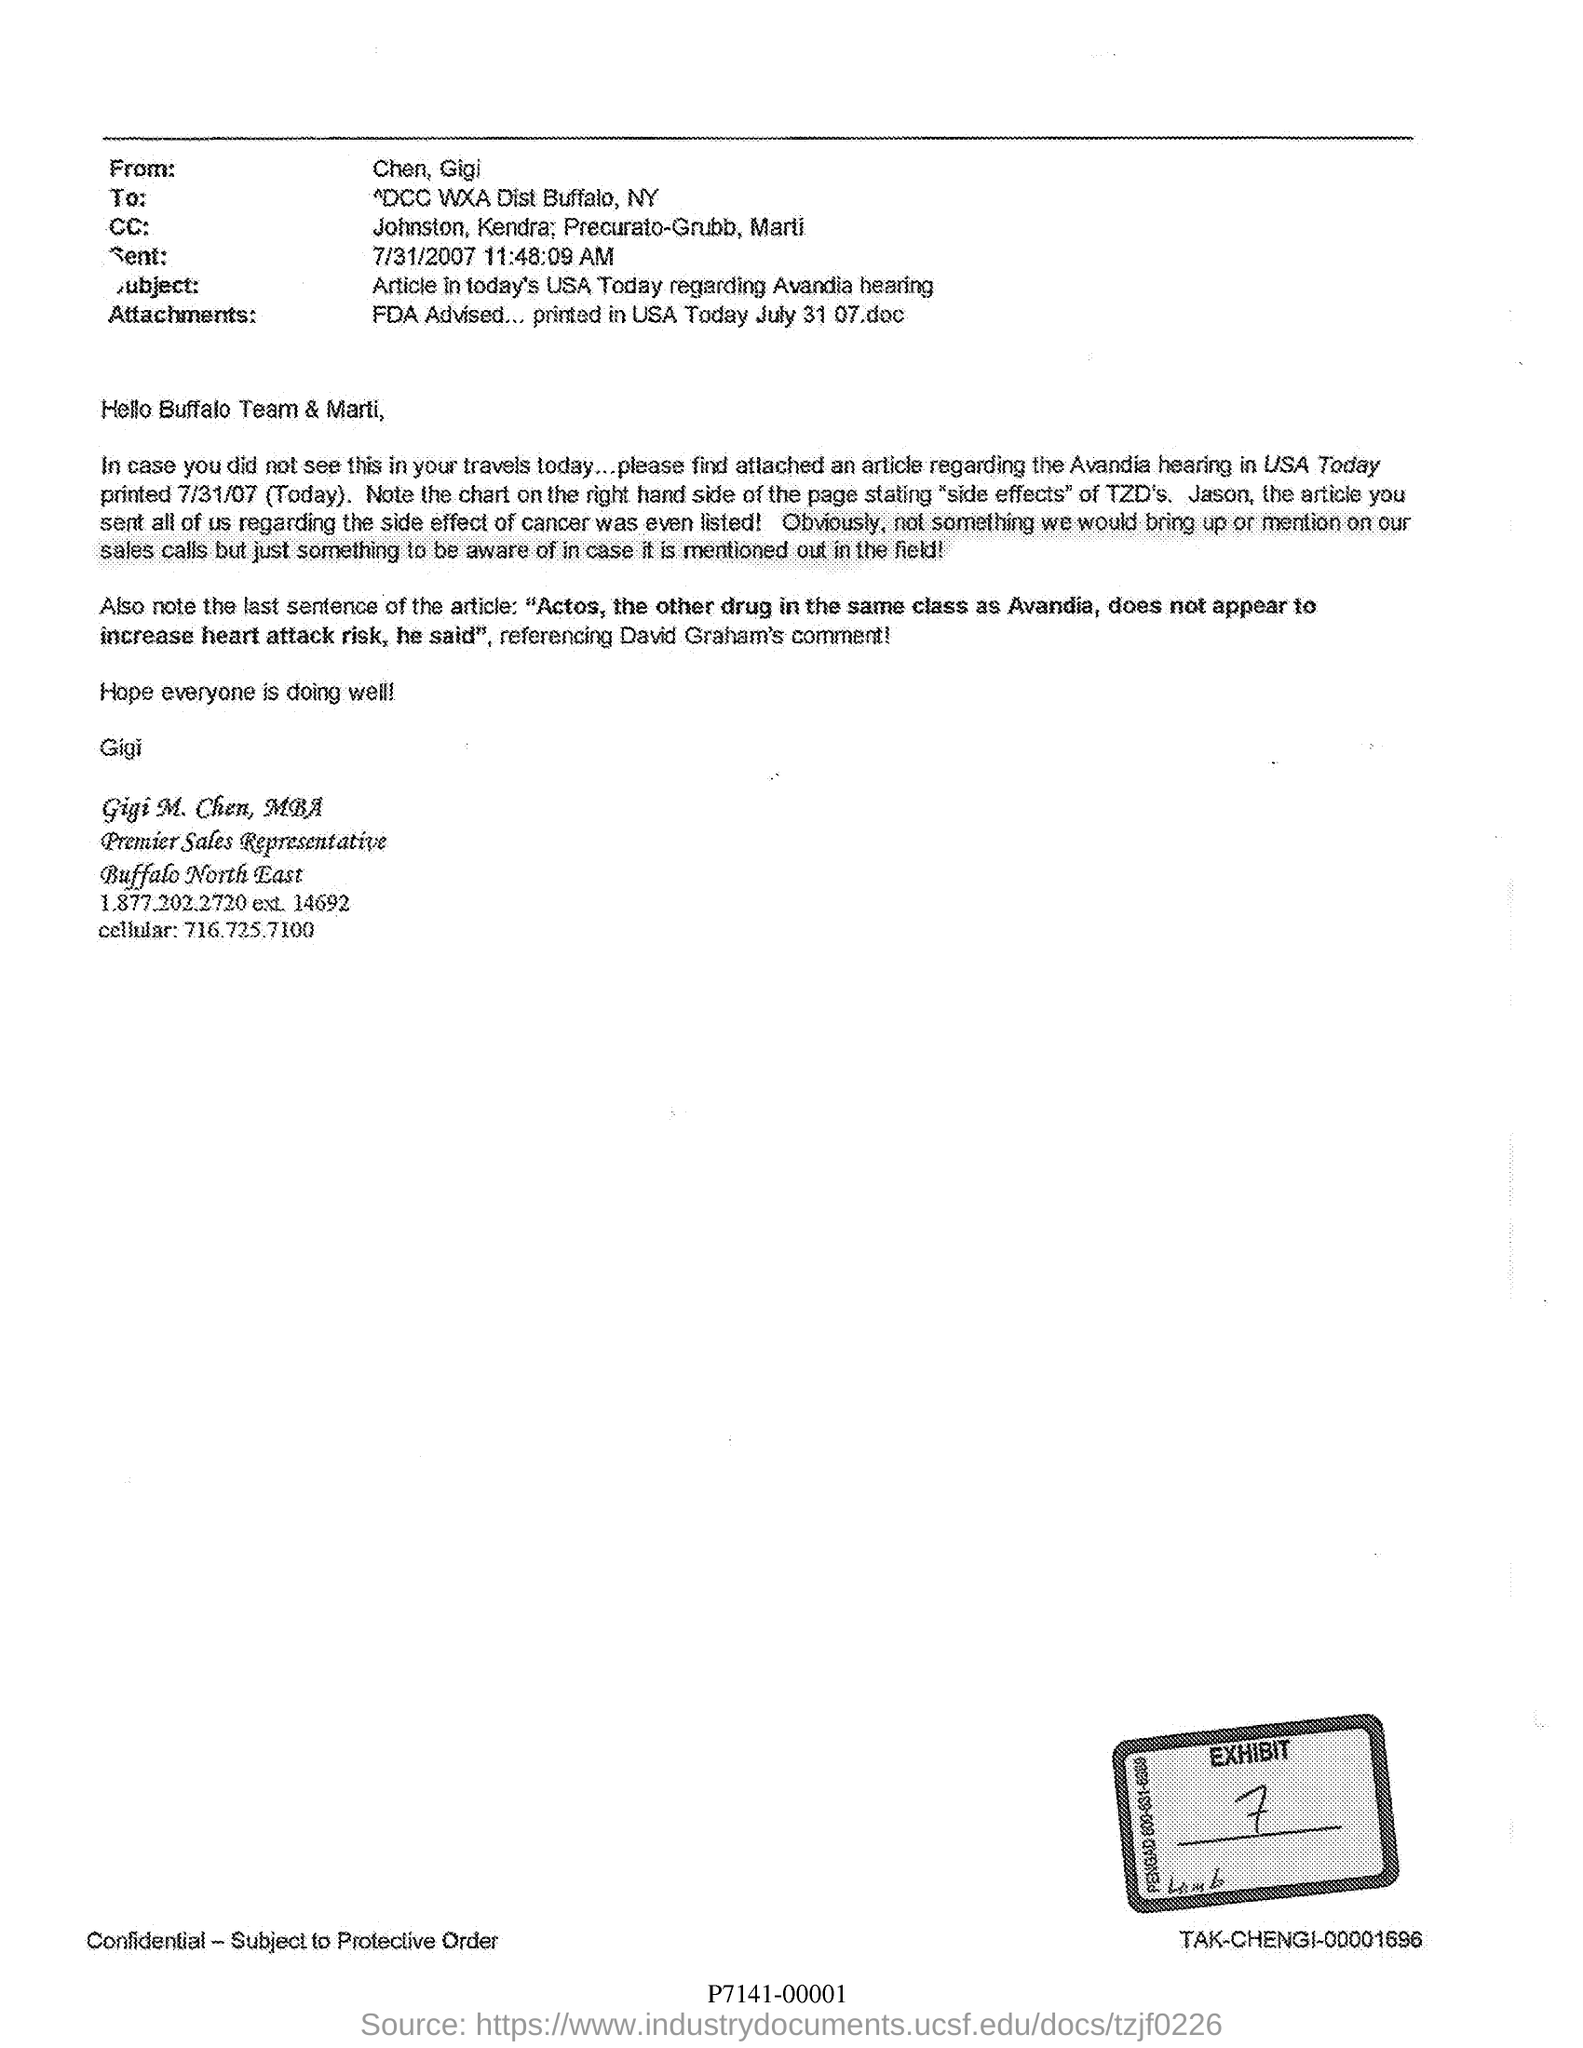Indicate a few pertinent items in this graphic. The writer of this letter is CHEN and GIGI. Gigi M. Chen's cellular number is 716.725.7100. The subject of the article in today's USA Today regarding the Avandia hearing is the Avandia medication. On July 31, 2007, at 11:48:09 AM, this letter was sent. Gigi M. Chen, MBA, is the premier sales representative. 